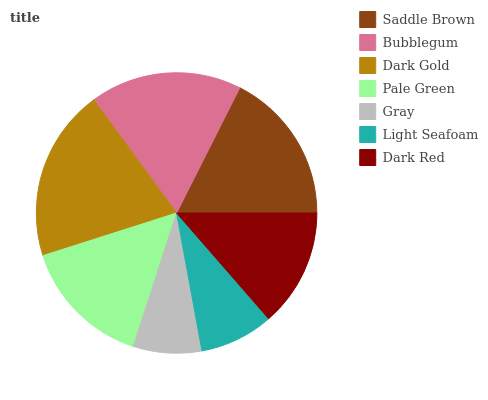Is Gray the minimum?
Answer yes or no. Yes. Is Dark Gold the maximum?
Answer yes or no. Yes. Is Bubblegum the minimum?
Answer yes or no. No. Is Bubblegum the maximum?
Answer yes or no. No. Is Saddle Brown greater than Bubblegum?
Answer yes or no. Yes. Is Bubblegum less than Saddle Brown?
Answer yes or no. Yes. Is Bubblegum greater than Saddle Brown?
Answer yes or no. No. Is Saddle Brown less than Bubblegum?
Answer yes or no. No. Is Pale Green the high median?
Answer yes or no. Yes. Is Pale Green the low median?
Answer yes or no. Yes. Is Saddle Brown the high median?
Answer yes or no. No. Is Light Seafoam the low median?
Answer yes or no. No. 